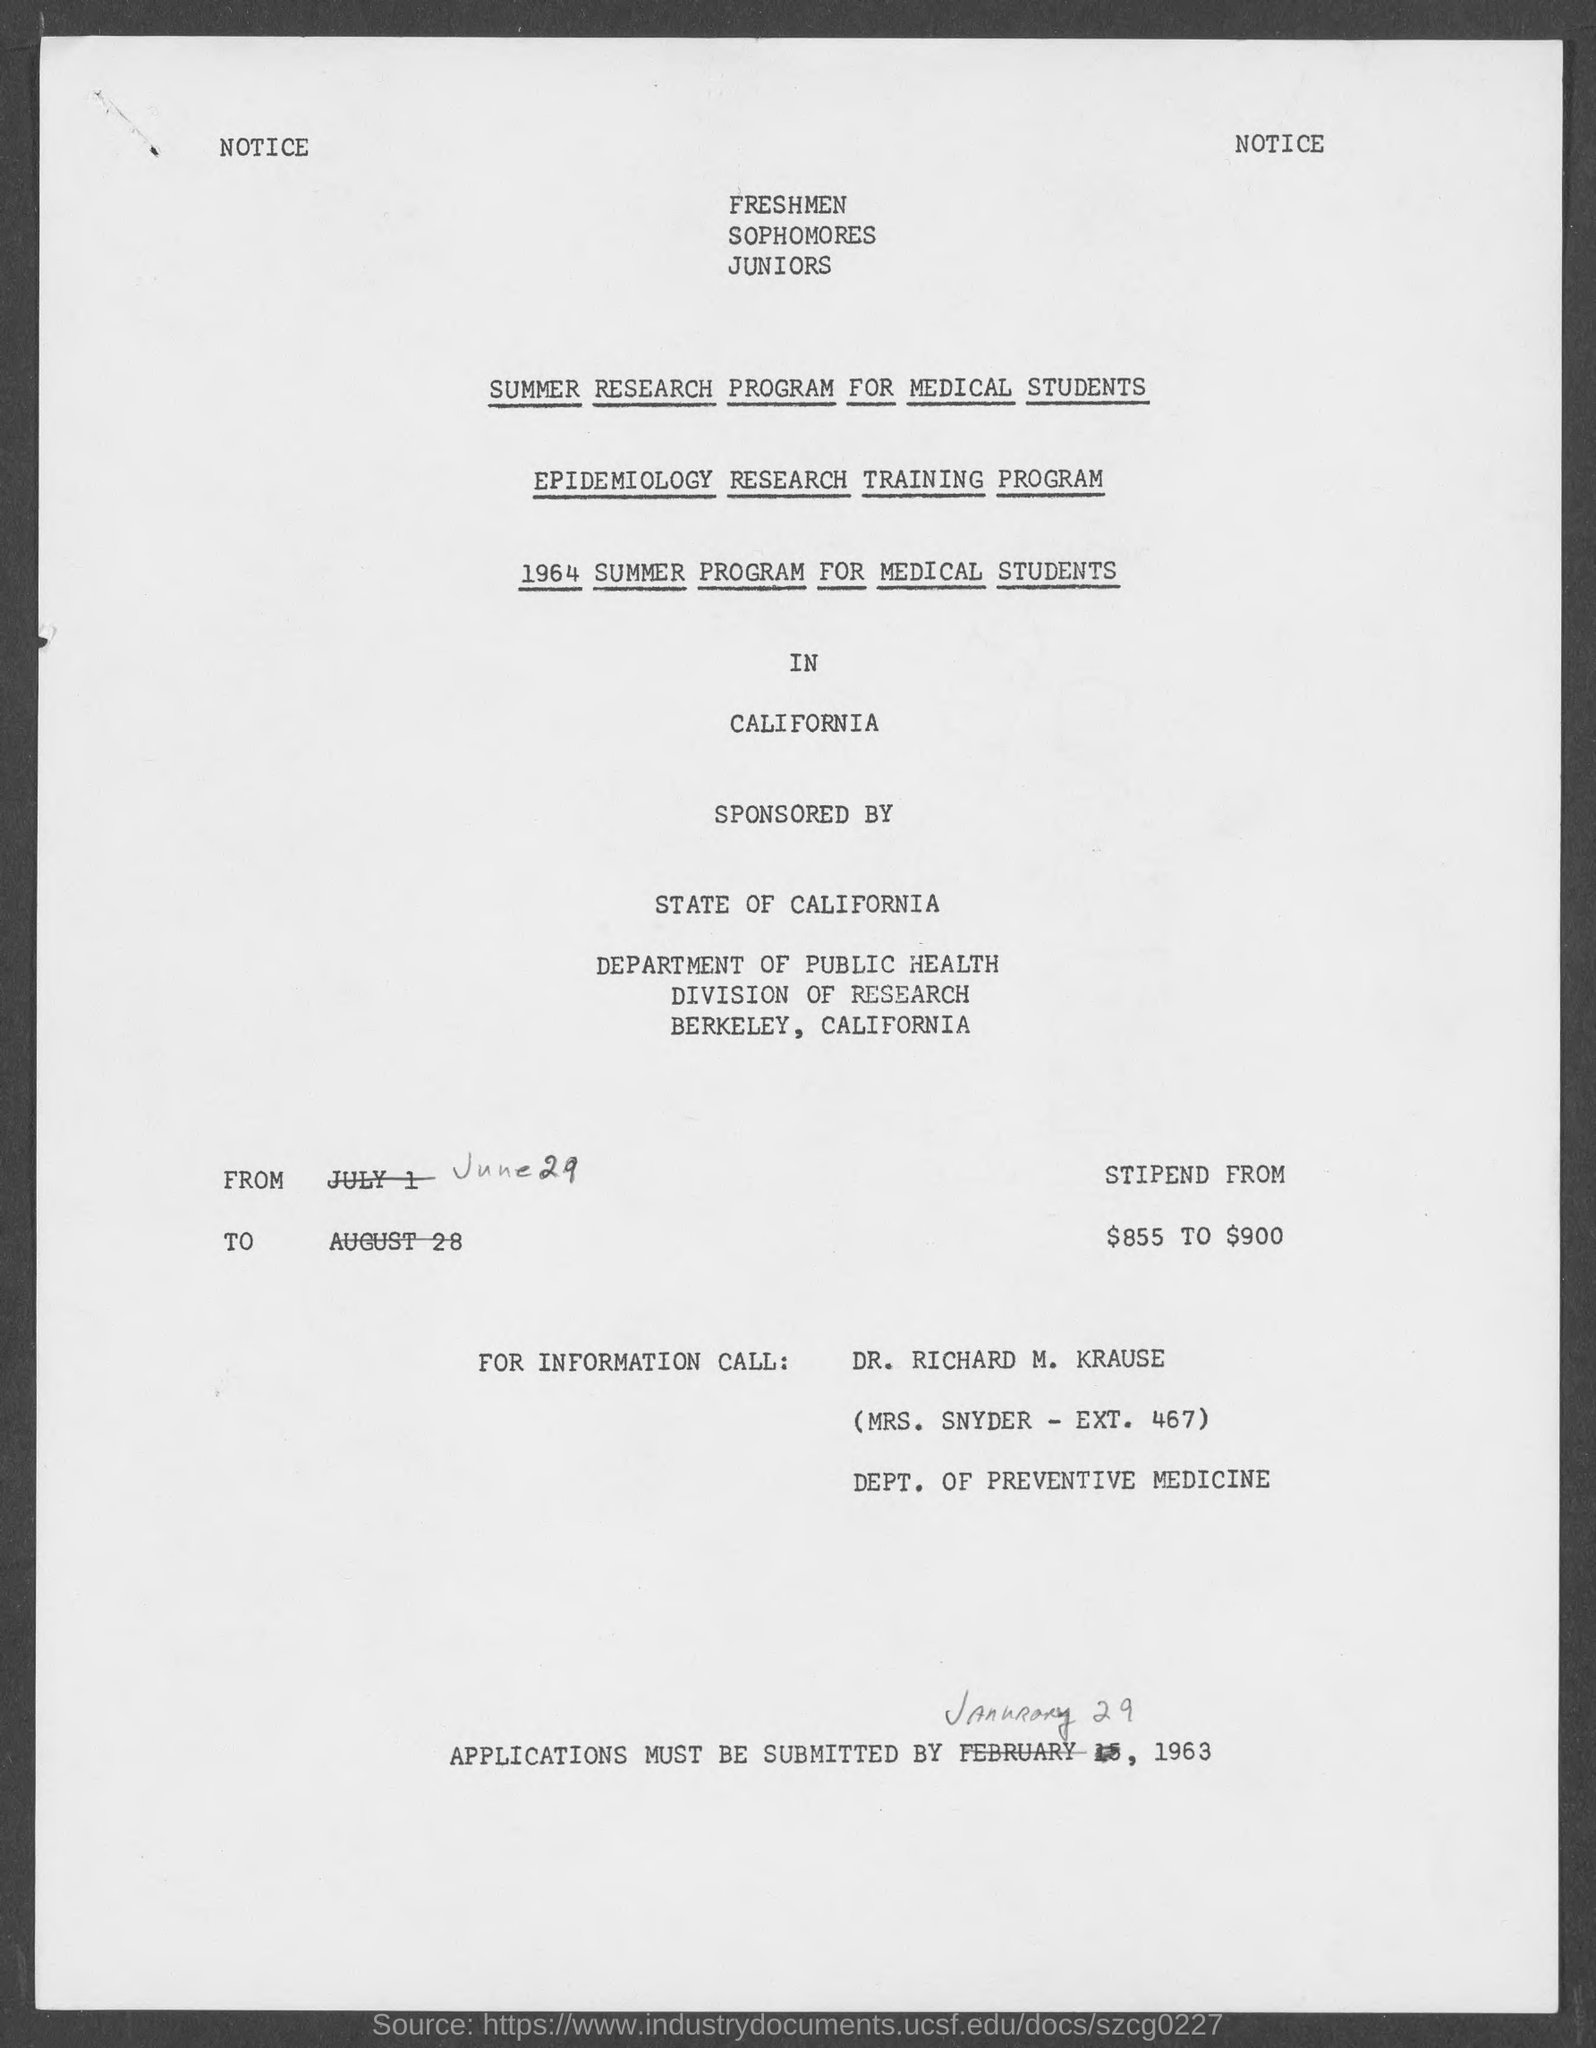What is the Stipend?
Your answer should be very brief. From $855 to $900. Applications must be submitted by when?
Give a very brief answer. January 29, 1963. 